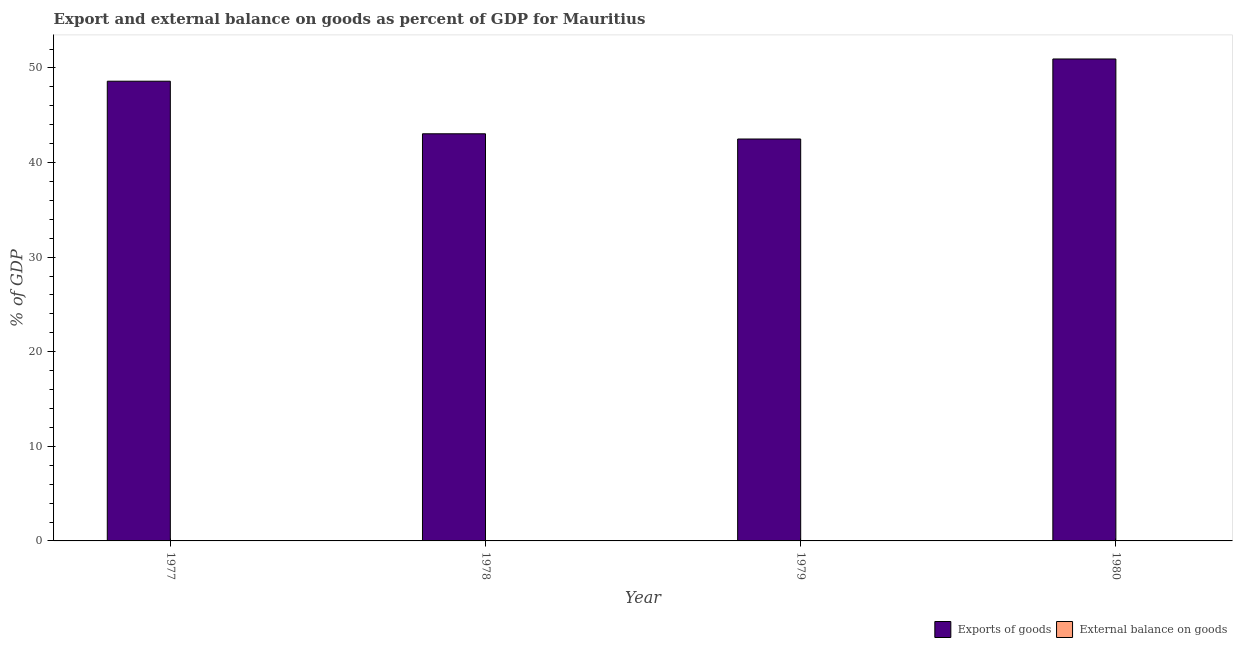How many different coloured bars are there?
Offer a very short reply. 1. Are the number of bars per tick equal to the number of legend labels?
Provide a short and direct response. No. What is the label of the 3rd group of bars from the left?
Make the answer very short. 1979. Across all years, what is the maximum export of goods as percentage of gdp?
Your answer should be very brief. 50.95. Across all years, what is the minimum external balance on goods as percentage of gdp?
Your response must be concise. 0. In which year was the export of goods as percentage of gdp maximum?
Your response must be concise. 1980. What is the total export of goods as percentage of gdp in the graph?
Your response must be concise. 185.09. What is the difference between the export of goods as percentage of gdp in 1979 and that in 1980?
Your response must be concise. -8.46. What is the difference between the export of goods as percentage of gdp in 1977 and the external balance on goods as percentage of gdp in 1978?
Your response must be concise. 5.56. What is the average external balance on goods as percentage of gdp per year?
Make the answer very short. 0. In the year 1979, what is the difference between the export of goods as percentage of gdp and external balance on goods as percentage of gdp?
Your answer should be compact. 0. What is the ratio of the export of goods as percentage of gdp in 1979 to that in 1980?
Ensure brevity in your answer.  0.83. What is the difference between the highest and the second highest export of goods as percentage of gdp?
Your response must be concise. 2.35. What is the difference between the highest and the lowest export of goods as percentage of gdp?
Give a very brief answer. 8.46. In how many years, is the external balance on goods as percentage of gdp greater than the average external balance on goods as percentage of gdp taken over all years?
Keep it short and to the point. 0. How many bars are there?
Offer a terse response. 4. Are all the bars in the graph horizontal?
Offer a very short reply. No. What is the difference between two consecutive major ticks on the Y-axis?
Your response must be concise. 10. Does the graph contain any zero values?
Give a very brief answer. Yes. What is the title of the graph?
Keep it short and to the point. Export and external balance on goods as percent of GDP for Mauritius. What is the label or title of the Y-axis?
Provide a succinct answer. % of GDP. What is the % of GDP of Exports of goods in 1977?
Provide a short and direct response. 48.6. What is the % of GDP in Exports of goods in 1978?
Keep it short and to the point. 43.04. What is the % of GDP of External balance on goods in 1978?
Provide a short and direct response. 0. What is the % of GDP in Exports of goods in 1979?
Keep it short and to the point. 42.49. What is the % of GDP in Exports of goods in 1980?
Provide a short and direct response. 50.95. What is the % of GDP in External balance on goods in 1980?
Make the answer very short. 0. Across all years, what is the maximum % of GDP in Exports of goods?
Offer a terse response. 50.95. Across all years, what is the minimum % of GDP in Exports of goods?
Make the answer very short. 42.49. What is the total % of GDP of Exports of goods in the graph?
Offer a terse response. 185.09. What is the difference between the % of GDP of Exports of goods in 1977 and that in 1978?
Your answer should be very brief. 5.56. What is the difference between the % of GDP in Exports of goods in 1977 and that in 1979?
Offer a terse response. 6.11. What is the difference between the % of GDP of Exports of goods in 1977 and that in 1980?
Offer a very short reply. -2.35. What is the difference between the % of GDP of Exports of goods in 1978 and that in 1979?
Your answer should be very brief. 0.55. What is the difference between the % of GDP of Exports of goods in 1978 and that in 1980?
Your answer should be very brief. -7.91. What is the difference between the % of GDP of Exports of goods in 1979 and that in 1980?
Offer a terse response. -8.46. What is the average % of GDP in Exports of goods per year?
Offer a terse response. 46.27. What is the average % of GDP in External balance on goods per year?
Your answer should be compact. 0. What is the ratio of the % of GDP in Exports of goods in 1977 to that in 1978?
Offer a very short reply. 1.13. What is the ratio of the % of GDP of Exports of goods in 1977 to that in 1979?
Your answer should be compact. 1.14. What is the ratio of the % of GDP of Exports of goods in 1977 to that in 1980?
Provide a short and direct response. 0.95. What is the ratio of the % of GDP in Exports of goods in 1978 to that in 1979?
Your answer should be compact. 1.01. What is the ratio of the % of GDP of Exports of goods in 1978 to that in 1980?
Give a very brief answer. 0.84. What is the ratio of the % of GDP of Exports of goods in 1979 to that in 1980?
Your response must be concise. 0.83. What is the difference between the highest and the second highest % of GDP in Exports of goods?
Provide a short and direct response. 2.35. What is the difference between the highest and the lowest % of GDP of Exports of goods?
Ensure brevity in your answer.  8.46. 